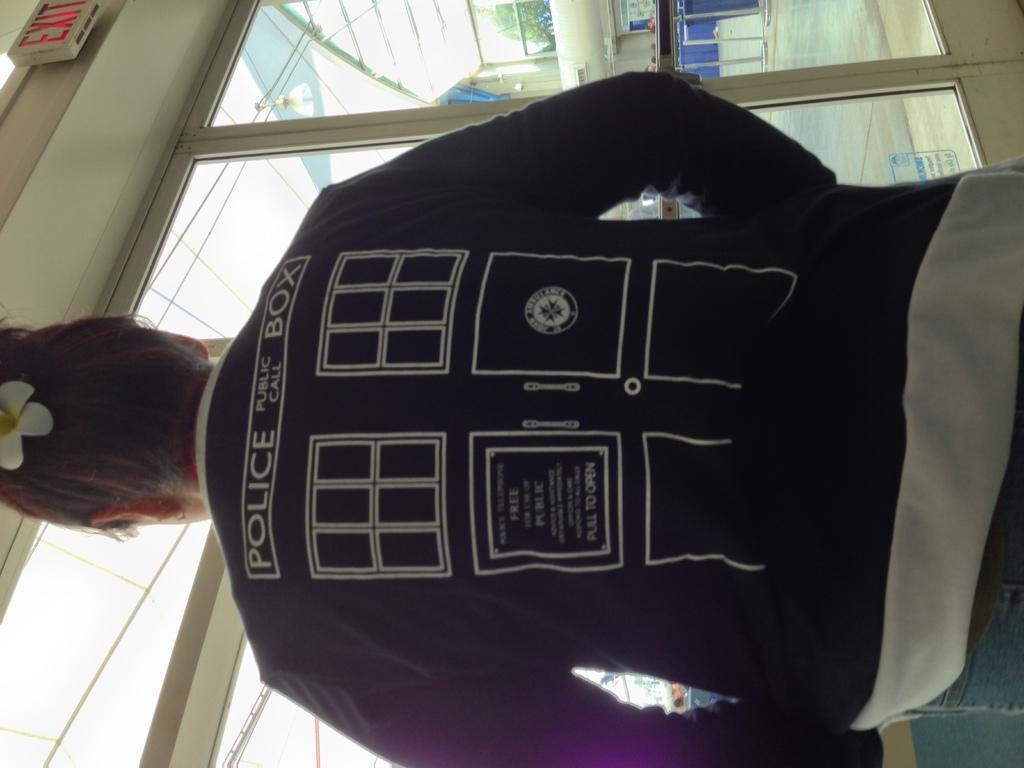Could you give a brief overview of what you see in this image? In the image we can see a person standing, wearing clothes and the person is facing back. Here we can see the glass window and out of the window we can see the tree, floor and the building. 